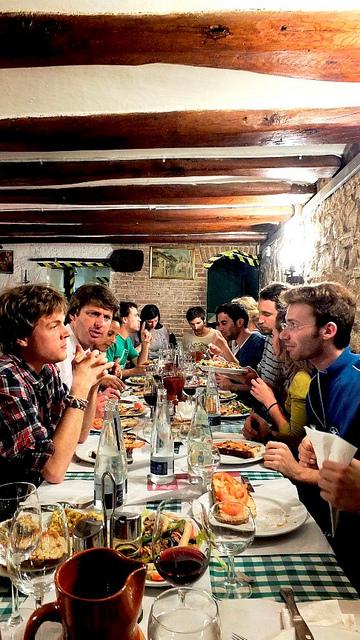Are the men ignoring one another?
Quick response, please. No. Where are the plates?
Answer briefly. On table. Are the people eating?
Keep it brief. Yes. 